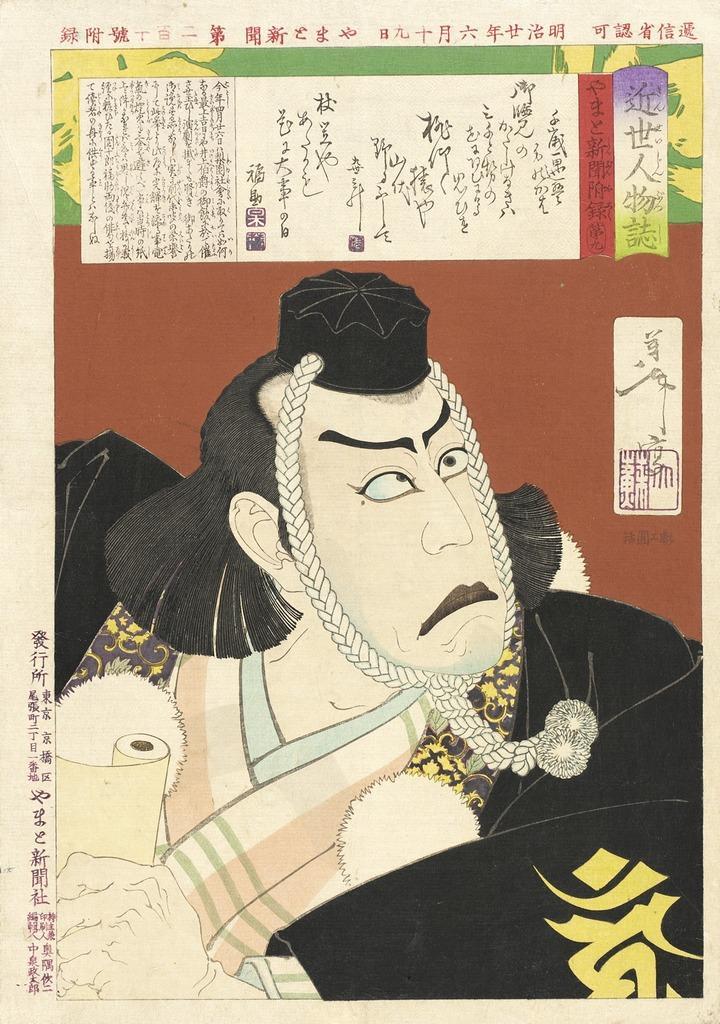Can you describe this image briefly? In this image there is a cartoon photograph published in a newspaper. 